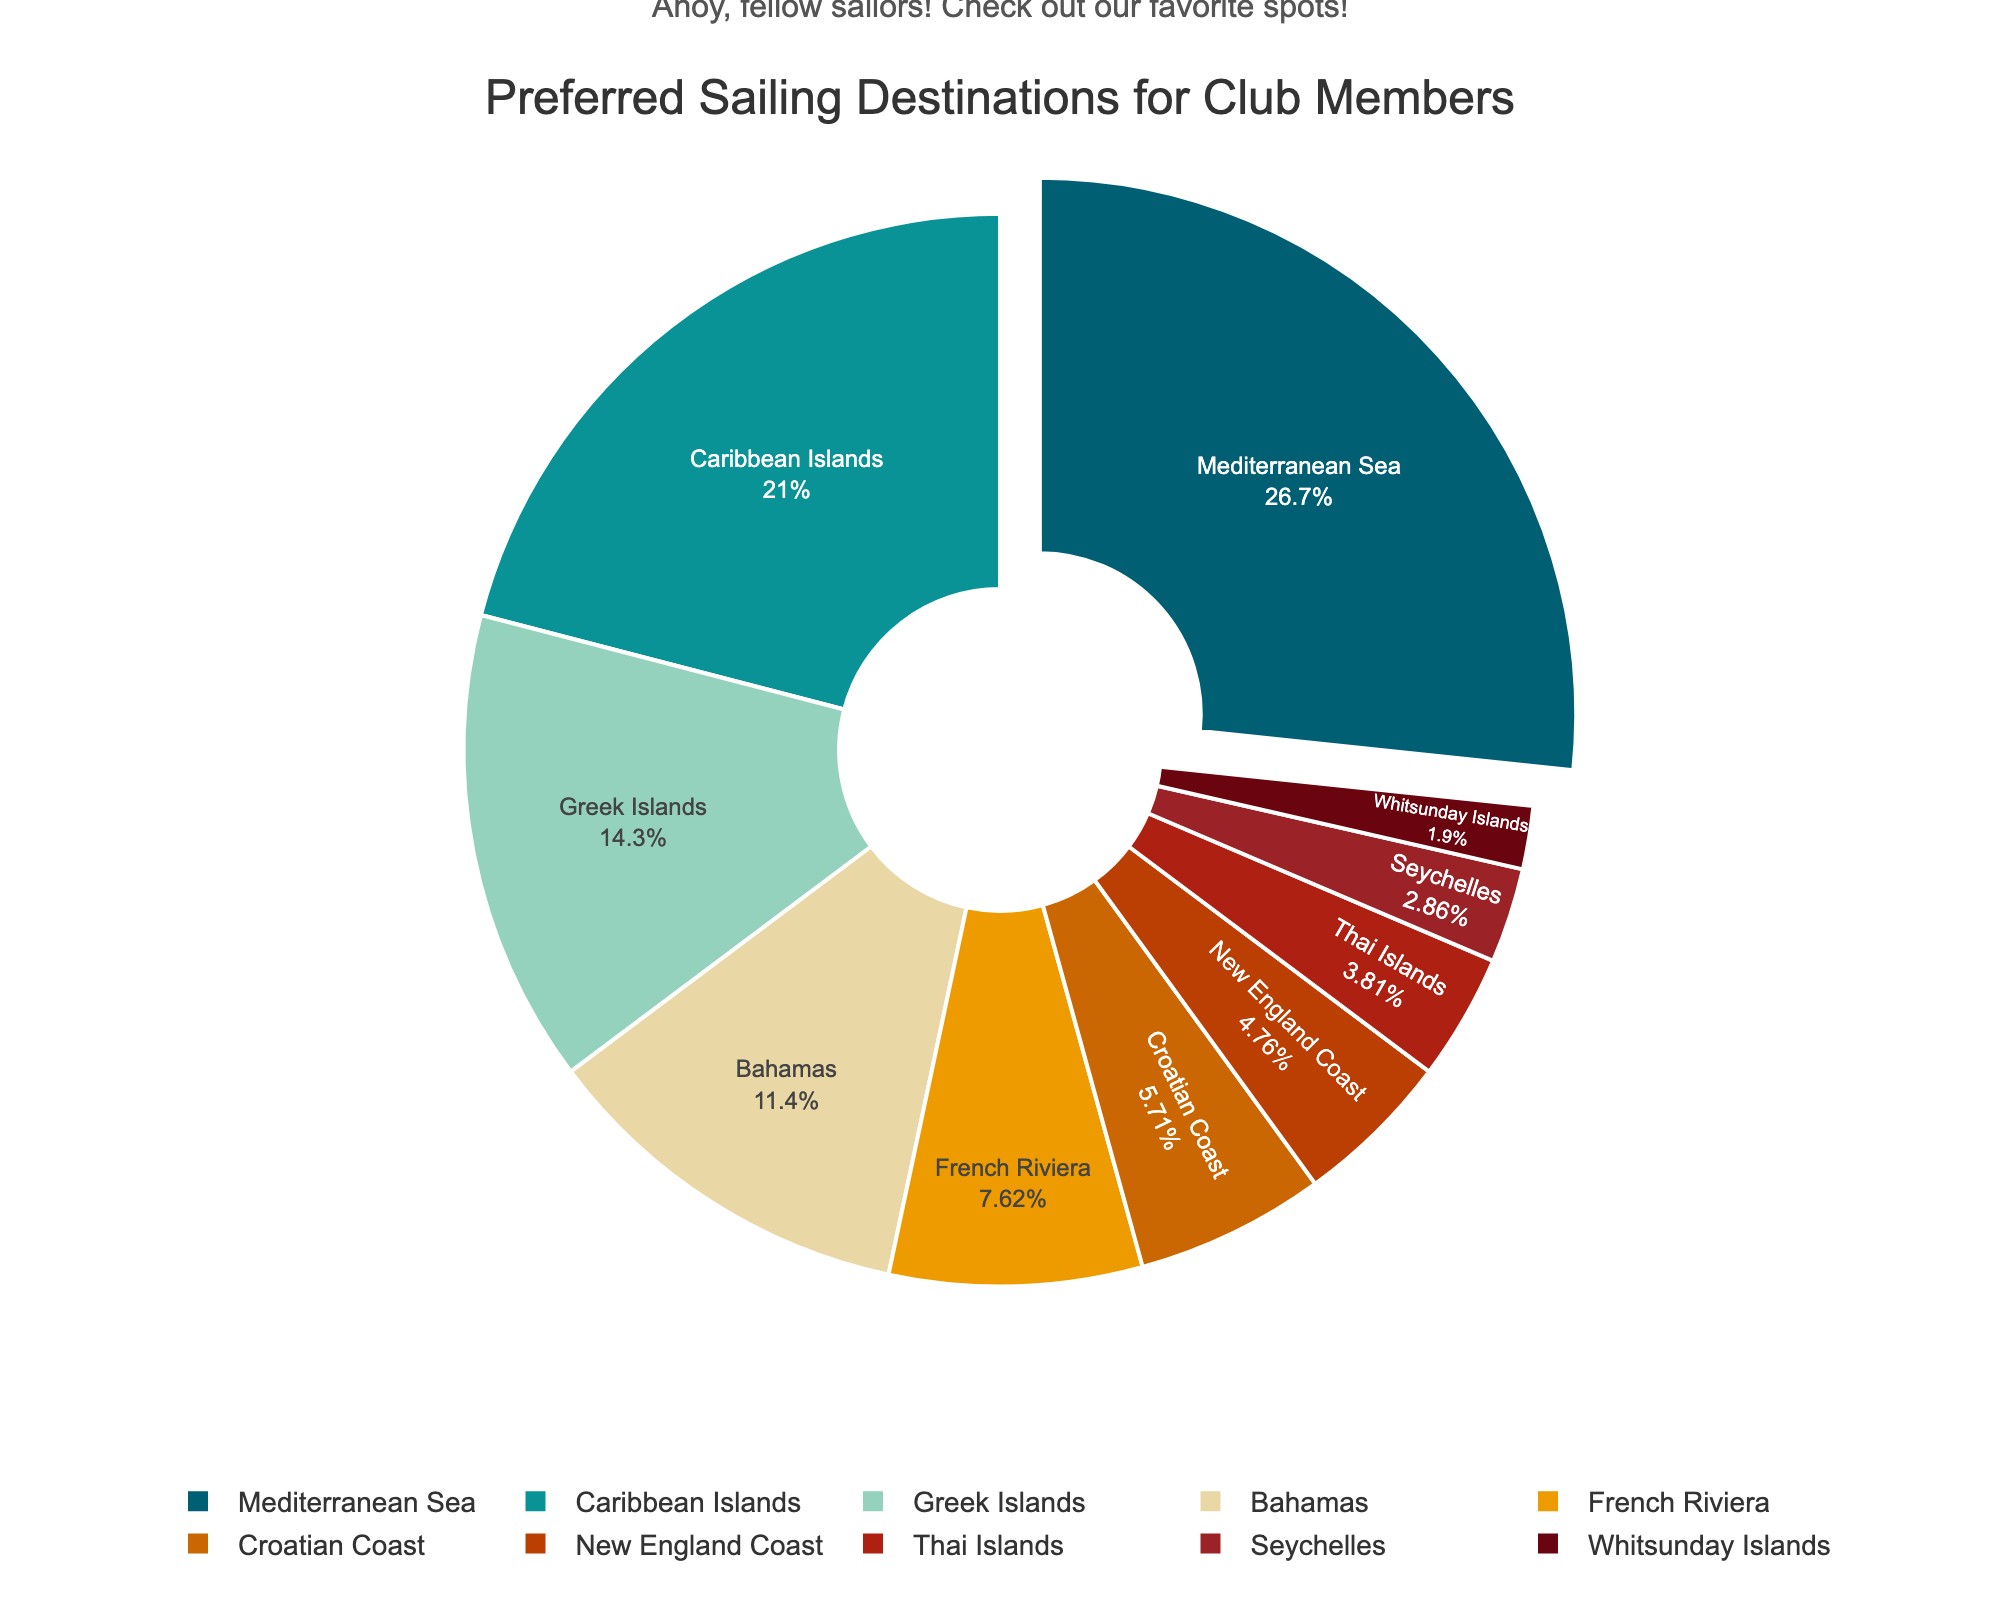Which destination has the highest preference among club members? The Mediterranean Sea has the largest portion of the pie chart, indicating it has the highest preference.
Answer: Mediterranean Sea Which two destinations have the lowest preference combined? The Whitsunday Islands and Seychelles have the smallest portions, adding up to 2% + 3% = 5%.
Answer: Whitsunday Islands and Seychelles How many destinations have a preference higher than 10%? By observing the pie chart, Mediterranean Sea (28%), Caribbean Islands (22%), Greek Islands (15%), and Bahamas (12%) are higher than 10%. This totals to four destinations.
Answer: Four What is the combined preference percentage for Mediterranean Sea and Caribbean Islands? The Mediterranean Sea has 28%, and the Caribbean Islands have 22%, so together it's 28% + 22% = 50%.
Answer: 50% Which destination follows Caribbean Islands in terms of preference? The Greek Islands follow the Caribbean Islands in preference with 15% according to the pie chart.
Answer: Greek Islands Are there more destinations with a preference below or above 10%? There are 6 destinations below 10% (French Riviera, Croatian Coast, New England Coast, Thai Islands, Seychelles, Whitsunday Islands) and 4 destinations above 10% (Mediterranean Sea, Caribbean Islands, Greek Islands, Bahamas).
Answer: Below 10% Which two destinations have preferences closest in value? The Croatian Coast and the New England Coast have the closest preference values of 6% and 5% respectively.
Answer: Croatian Coast and New England Coast How much higher is the preference for the Mediterranean Sea compared to the Greek Islands? The Mediterranean Sea has a preference of 28%, and the Greek Islands have 15%, so the difference is 28% - 15% = 13%.
Answer: 13% Which destination has a higher preference, the French Riviera or the Thai Islands? The French Riviera has 8%, and the Thai Islands have 4%, so the French Riviera has a higher preference.
Answer: French Riviera 